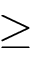Convert formula to latex. <formula><loc_0><loc_0><loc_500><loc_500>\geq</formula> 